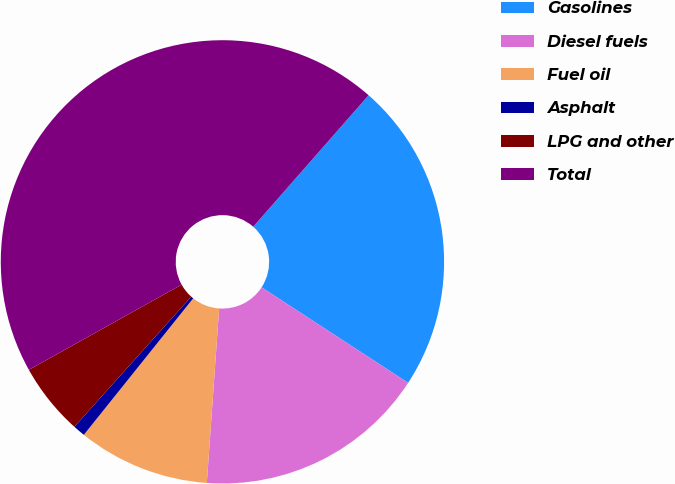Convert chart to OTSL. <chart><loc_0><loc_0><loc_500><loc_500><pie_chart><fcel>Gasolines<fcel>Diesel fuels<fcel>Fuel oil<fcel>Asphalt<fcel>LPG and other<fcel>Total<nl><fcel>22.73%<fcel>16.93%<fcel>9.63%<fcel>0.89%<fcel>5.26%<fcel>44.56%<nl></chart> 